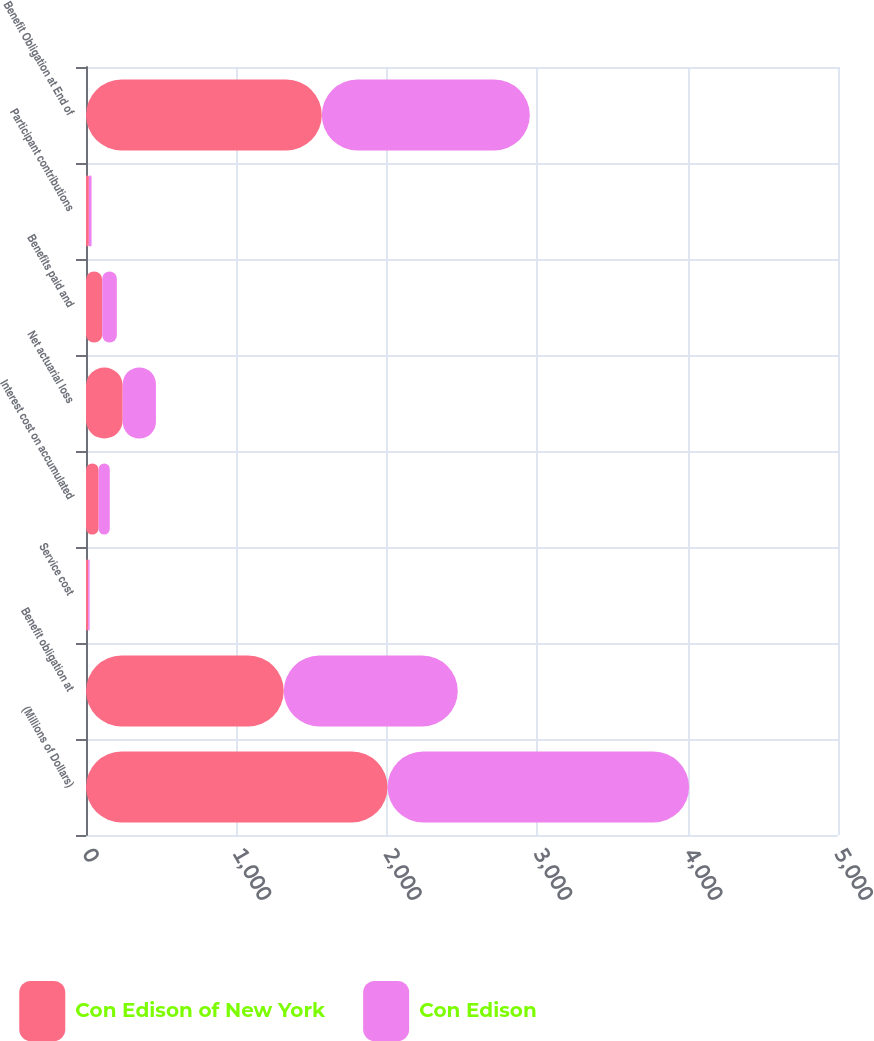Convert chart to OTSL. <chart><loc_0><loc_0><loc_500><loc_500><stacked_bar_chart><ecel><fcel>(Millions of Dollars)<fcel>Benefit obligation at<fcel>Service cost<fcel>Interest cost on accumulated<fcel>Net actuarial loss<fcel>Benefits paid and<fcel>Participant contributions<fcel>Benefit Obligation at End of<nl><fcel>Con Edison of New York<fcel>2005<fcel>1315<fcel>14<fcel>84<fcel>244<fcel>108<fcel>19<fcel>1568<nl><fcel>Con Edison<fcel>2005<fcel>1157<fcel>10<fcel>74<fcel>221<fcel>97<fcel>18<fcel>1383<nl></chart> 